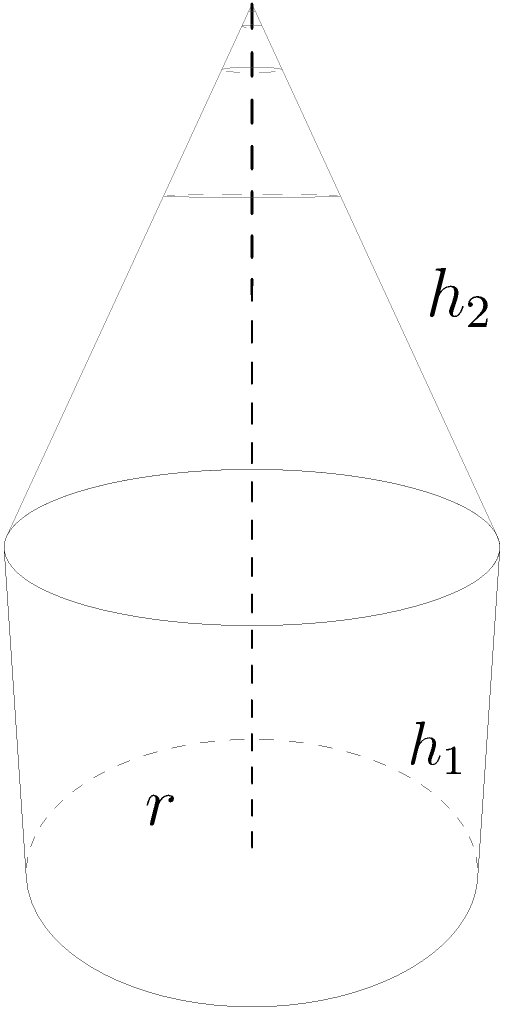Hey, Neeraj's friend! Remember that cool water tower we used to see in our hometown? It reminds me of this shape. The bottom part is a cylinder with radius 2 meters and height 3 meters. On top of it is a conical part with the same base radius and height 4 meters. What's the total volume of this structure? Let's break this down step-by-step:

1) First, we need to calculate the volume of the cylindrical part:
   $$V_{cylinder} = \pi r^2 h_1$$
   $$V_{cylinder} = \pi \cdot 2^2 \cdot 3 = 12\pi \text{ cubic meters}$$

2) Next, let's calculate the volume of the conical part:
   $$V_{cone} = \frac{1}{3} \pi r^2 h_2$$
   $$V_{cone} = \frac{1}{3} \pi \cdot 2^2 \cdot 4 = \frac{16\pi}{3} \text{ cubic meters}$$

3) Now, we add these volumes together:
   $$V_{total} = V_{cylinder} + V_{cone}$$
   $$V_{total} = 12\pi + \frac{16\pi}{3}$$

4) Let's simplify this:
   $$V_{total} = \frac{36\pi}{3} + \frac{16\pi}{3} = \frac{52\pi}{3} \text{ cubic meters}$$

Therefore, the total volume of the structure is $\frac{52\pi}{3}$ cubic meters.
Answer: $\frac{52\pi}{3}$ cubic meters 